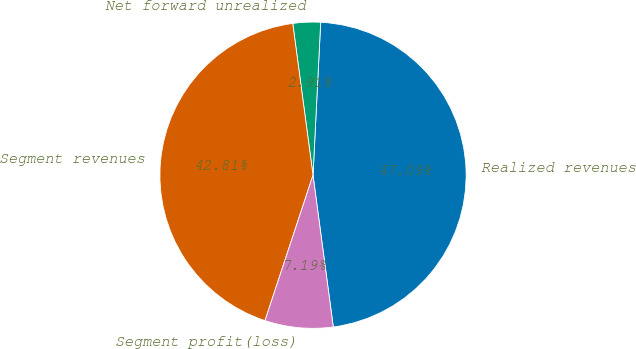Convert chart. <chart><loc_0><loc_0><loc_500><loc_500><pie_chart><fcel>Realized revenues<fcel>Net forward unrealized<fcel>Segment revenues<fcel>Segment profit(loss)<nl><fcel>47.09%<fcel>2.91%<fcel>42.81%<fcel>7.19%<nl></chart> 